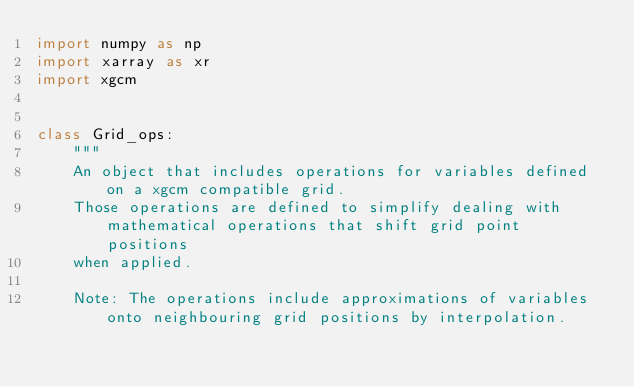<code> <loc_0><loc_0><loc_500><loc_500><_Python_>import numpy as np
import xarray as xr
import xgcm


class Grid_ops:
    """
    An object that includes operations for variables defined on a xgcm compatible grid.
    Those operations are defined to simplify dealing with mathematical operations that shift grid point positions
    when applied.

    Note: The operations include approximations of variables onto neighbouring grid positions by interpolation.</code> 